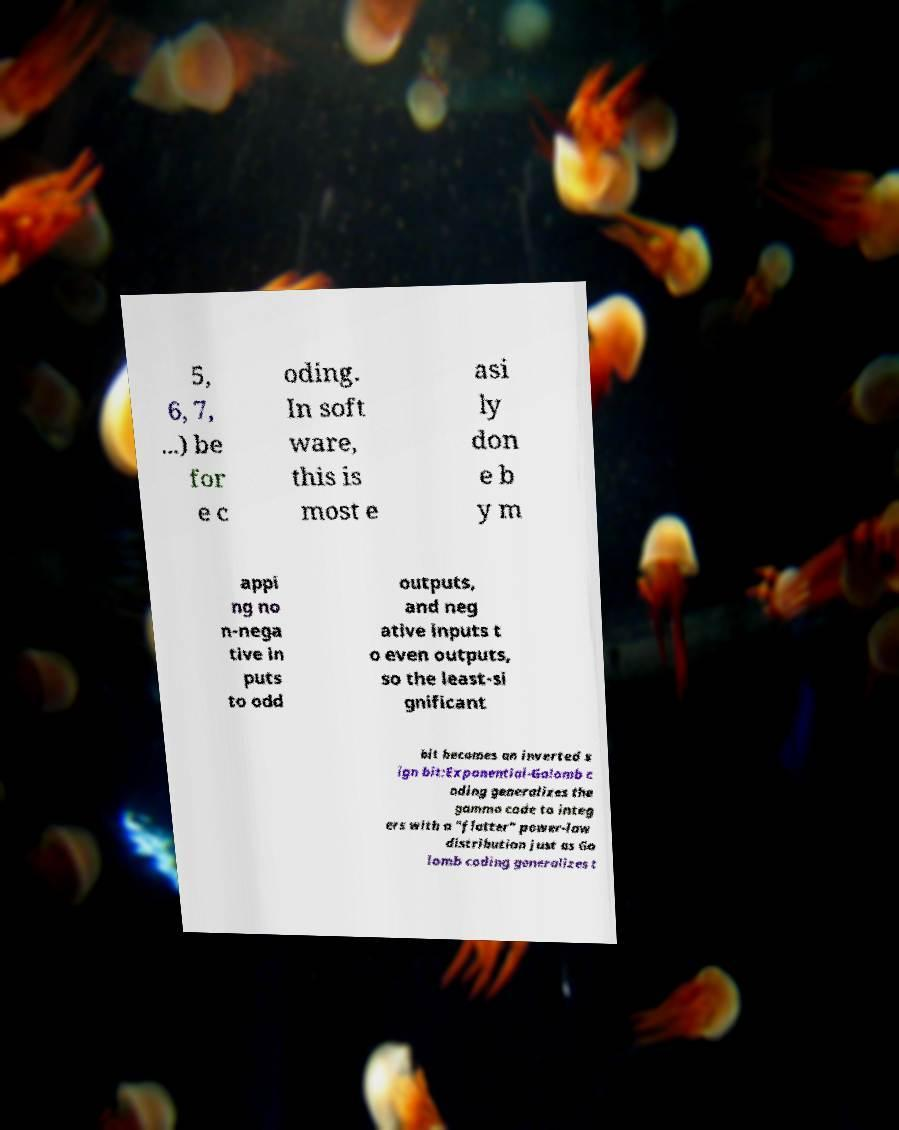I need the written content from this picture converted into text. Can you do that? 5, 6, 7, ...) be for e c oding. In soft ware, this is most e asi ly don e b y m appi ng no n-nega tive in puts to odd outputs, and neg ative inputs t o even outputs, so the least-si gnificant bit becomes an inverted s ign bit:Exponential-Golomb c oding generalizes the gamma code to integ ers with a "flatter" power-law distribution just as Go lomb coding generalizes t 